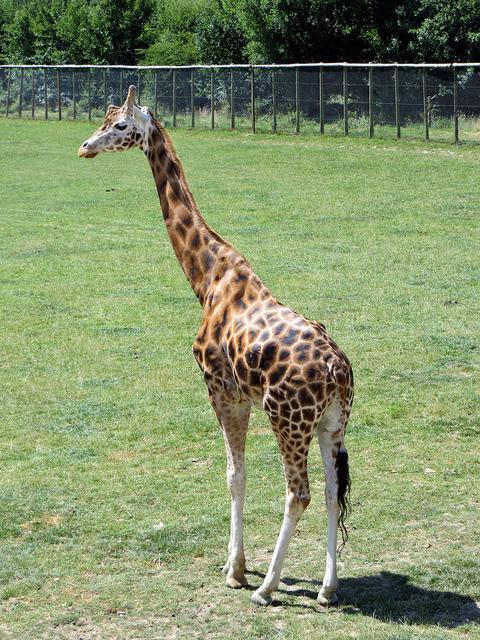How many legs does the giraffe have?
Give a very brief answer. 4. How many giraffes are there?
Give a very brief answer. 1. 